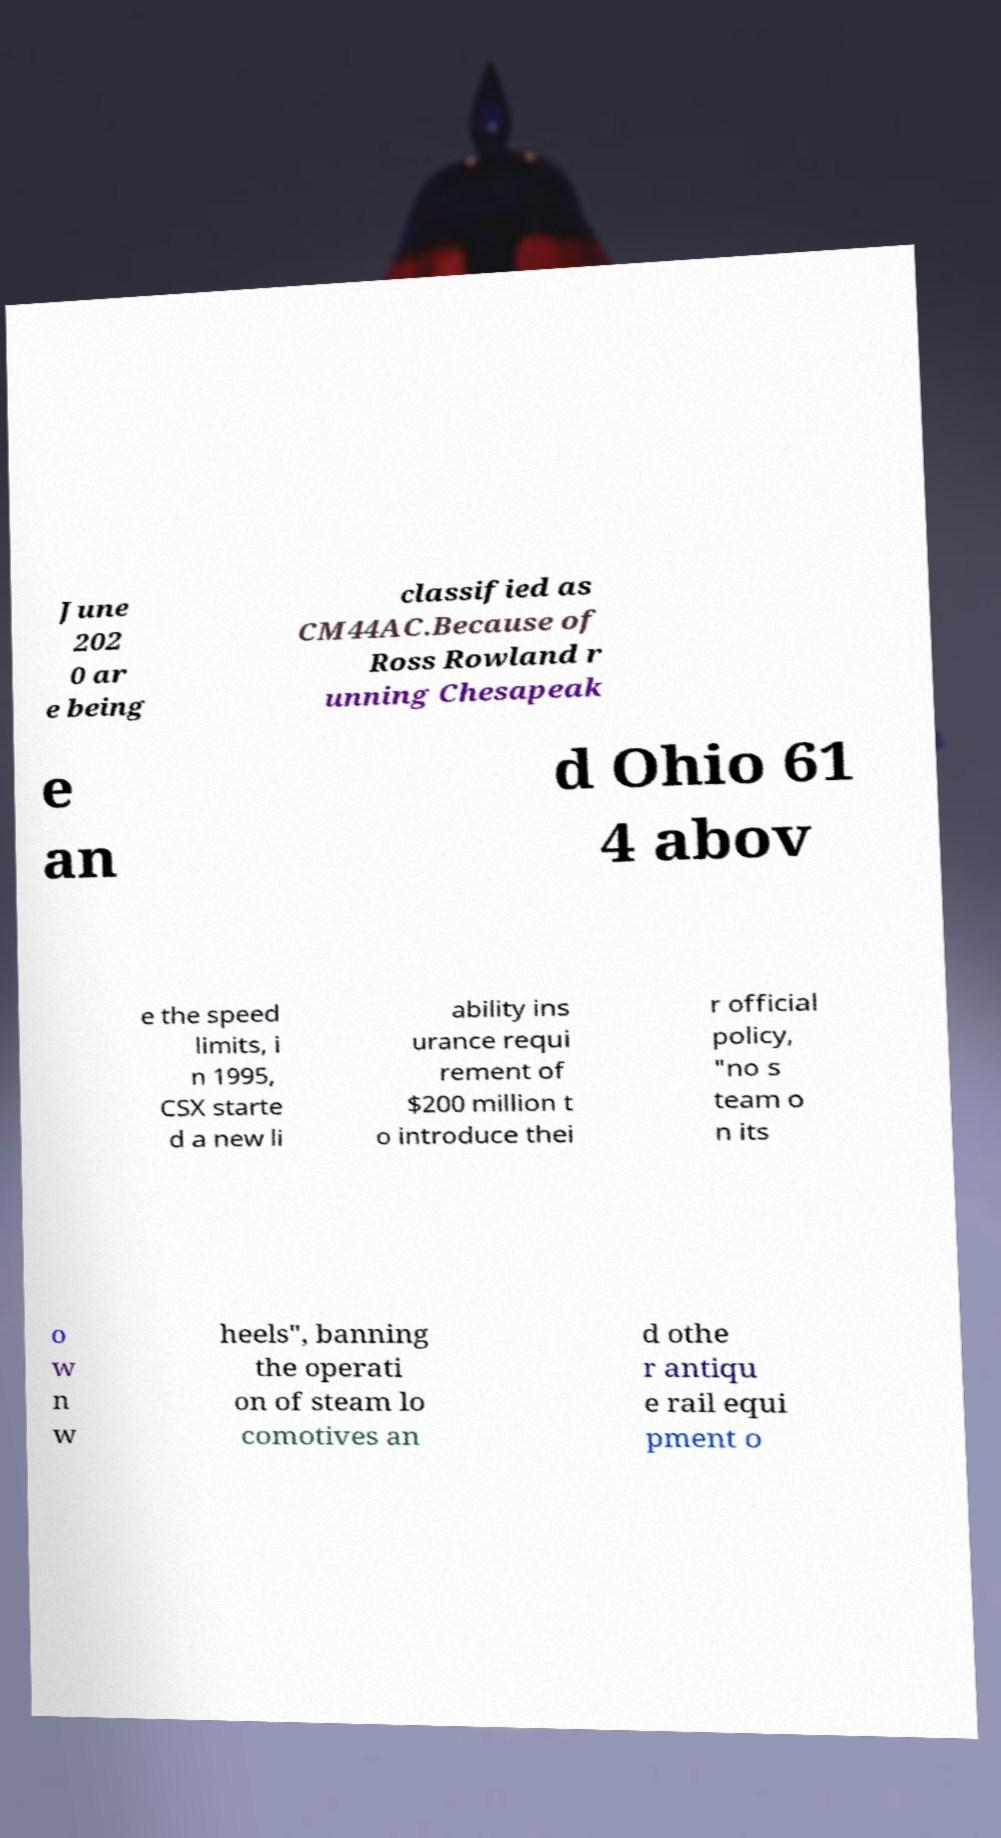Could you assist in decoding the text presented in this image and type it out clearly? June 202 0 ar e being classified as CM44AC.Because of Ross Rowland r unning Chesapeak e an d Ohio 61 4 abov e the speed limits, i n 1995, CSX starte d a new li ability ins urance requi rement of $200 million t o introduce thei r official policy, "no s team o n its o w n w heels", banning the operati on of steam lo comotives an d othe r antiqu e rail equi pment o 